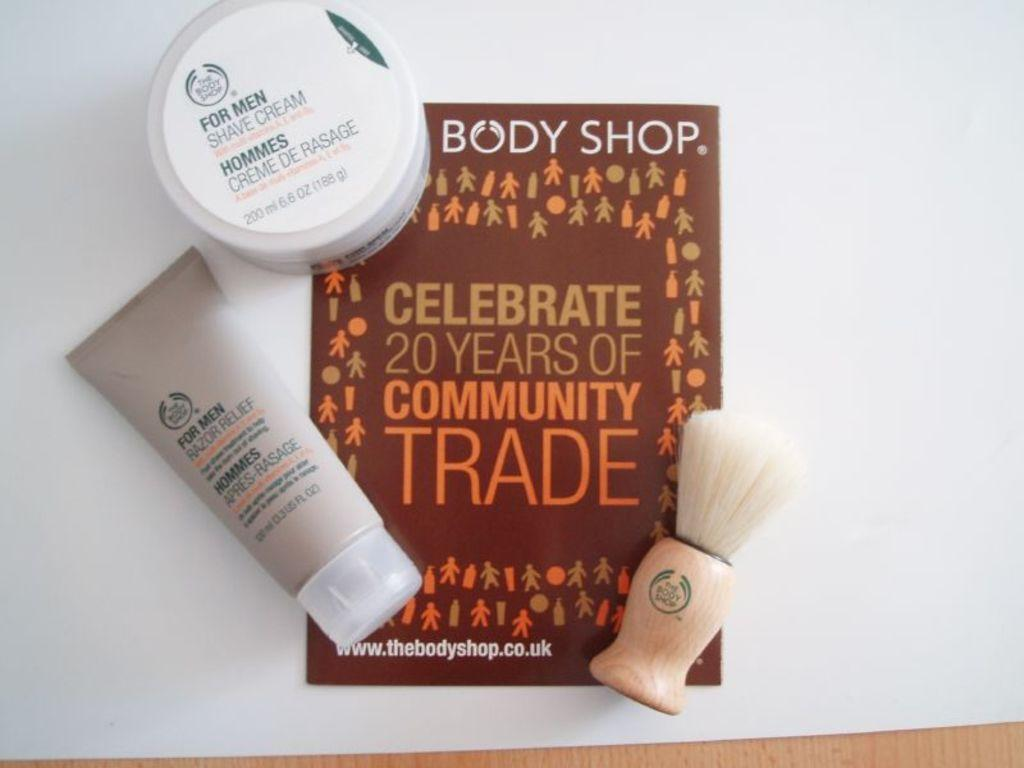<image>
Relay a brief, clear account of the picture shown. Body Shop Celebrate 20 yers of community trade book with 3 lotions. 